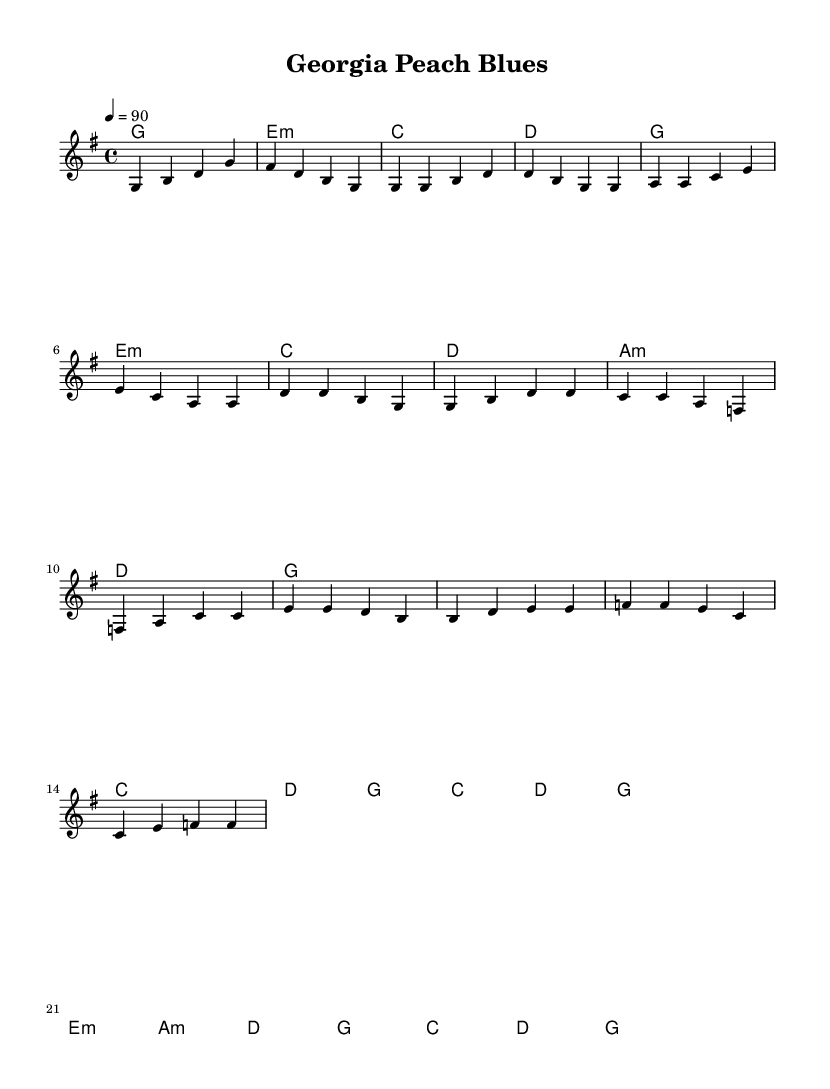What is the key signature of this music? The key signature is G major, which has one sharp (F#).
Answer: G major What is the time signature of this music? The time signature is 4/4, indicating four beats in a measure and a quarter note receives one beat.
Answer: 4/4 What is the tempo marking of the piece? The tempo marking is 90 beats per minute, indicated by the tempo text "4 = 90".
Answer: 90 How many measures are in the Chorus section? The Chorus is composed of 8 measures, as counted from the musical notation presented.
Answer: 8 What is the first chord in the Intro? The first chord is G major, which is the starting chord of the Intro.
Answer: G major Which chord leads into the bridge section? The bridge section starts with E minor, as the harmonies indicate this chord follows the Chorus leading into the Bridge.
Answer: E minor What is a characteristic of the rhythm and blues style evident in this piece? A characteristic is the inclusion of blues-infused elements, such as the use of minor chords and a strong backbeat, often felt in the melody and harmony.
Answer: Blues-infused elements 